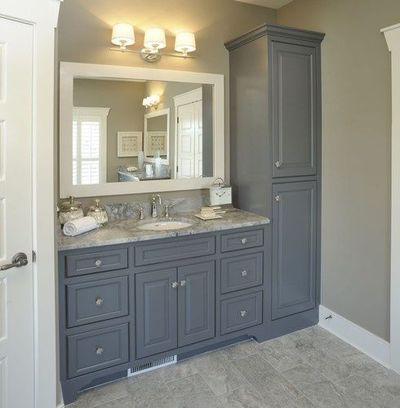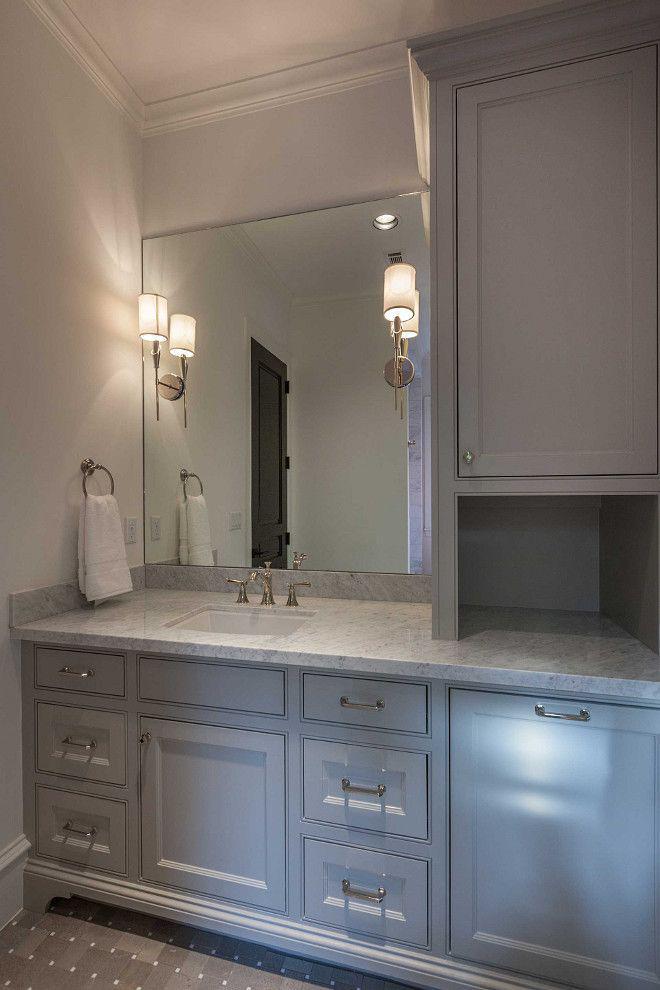The first image is the image on the left, the second image is the image on the right. Evaluate the accuracy of this statement regarding the images: "The right image features at least one round white bowl-shaped sink atop a vanity.". Is it true? Answer yes or no. No. 